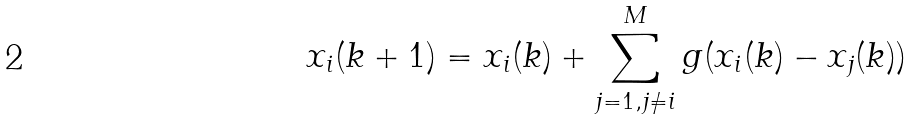Convert formula to latex. <formula><loc_0><loc_0><loc_500><loc_500>x _ { i } ( k + 1 ) = x _ { i } ( k ) + \sum _ { j = 1 , j \neq i } ^ { M } g ( x _ { i } ( k ) - x _ { j } ( k ) )</formula> 